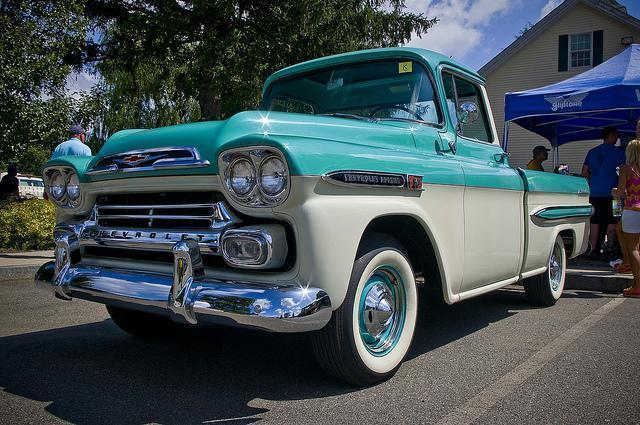What type of vehicle is shown?
Choose the correct response and explain in the format: 'Answer: answer
Rationale: rationale.'
Options: Subway, bus, car, train. Answer: car.
Rationale: The vehicle is actually a truck. 